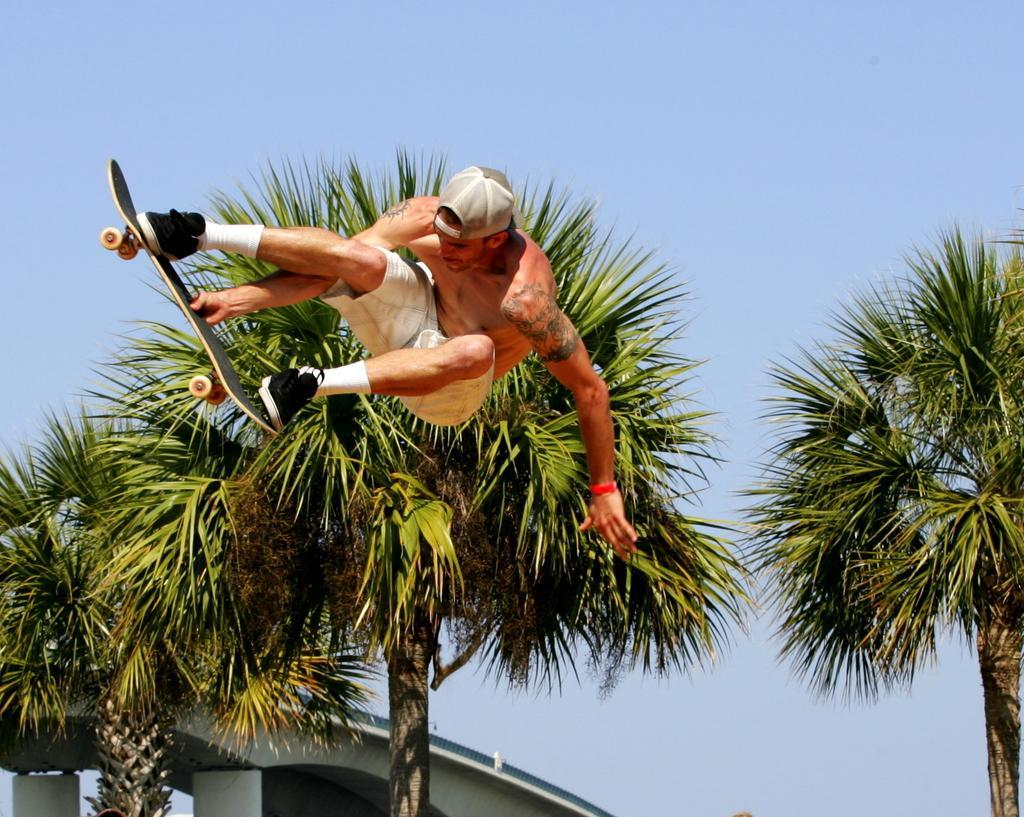Can you describe this image briefly? In this image I can see a person jumping on ski board and I can see the sky and tree 